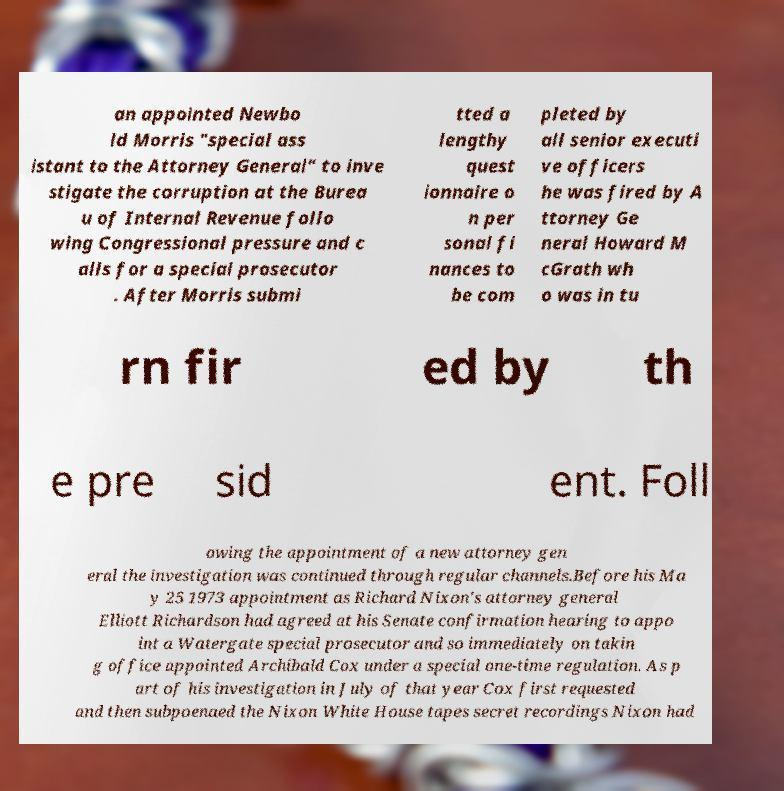For documentation purposes, I need the text within this image transcribed. Could you provide that? an appointed Newbo ld Morris "special ass istant to the Attorney General" to inve stigate the corruption at the Burea u of Internal Revenue follo wing Congressional pressure and c alls for a special prosecutor . After Morris submi tted a lengthy quest ionnaire o n per sonal fi nances to be com pleted by all senior executi ve officers he was fired by A ttorney Ge neral Howard M cGrath wh o was in tu rn fir ed by th e pre sid ent. Foll owing the appointment of a new attorney gen eral the investigation was continued through regular channels.Before his Ma y 25 1973 appointment as Richard Nixon's attorney general Elliott Richardson had agreed at his Senate confirmation hearing to appo int a Watergate special prosecutor and so immediately on takin g office appointed Archibald Cox under a special one-time regulation. As p art of his investigation in July of that year Cox first requested and then subpoenaed the Nixon White House tapes secret recordings Nixon had 